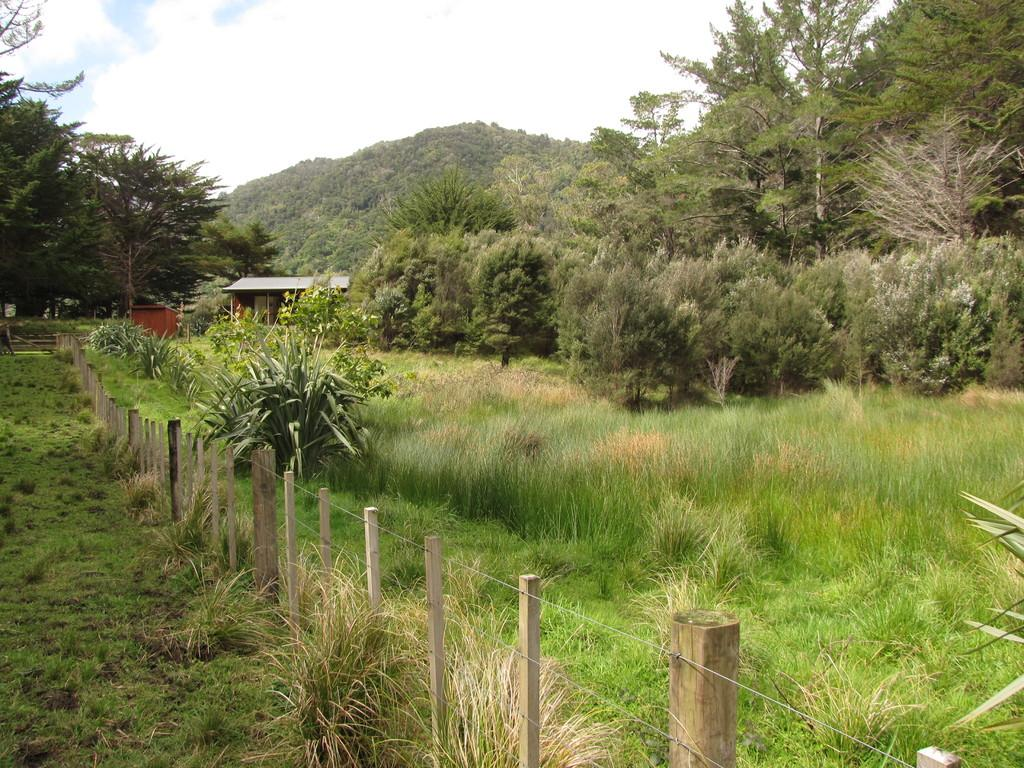What type of barrier can be seen in the image? There is a fence in the image. What type of vegetation is present on the ground in the image? Grass and plants are visible on the ground in the image. What type of structures are present in the image? There are sheds in the image. What type of natural elements are present in the image? Trees are present in the image. What else can be seen on the ground in the image? There are some unspecified objects in the image. What is visible in the background of the image? The sky is visible in the background of the image. What can be seen in the sky? Clouds are present in the sky. How many jelly slices are on the ground in the image? There is no jelly or jelly slices present in the image. What type of snake can be seen slithering through the grass in the image? There are no snakes present in the image; it features a fence, grass, plants, sheds, trees, unspecified objects, and a sky with clouds. 